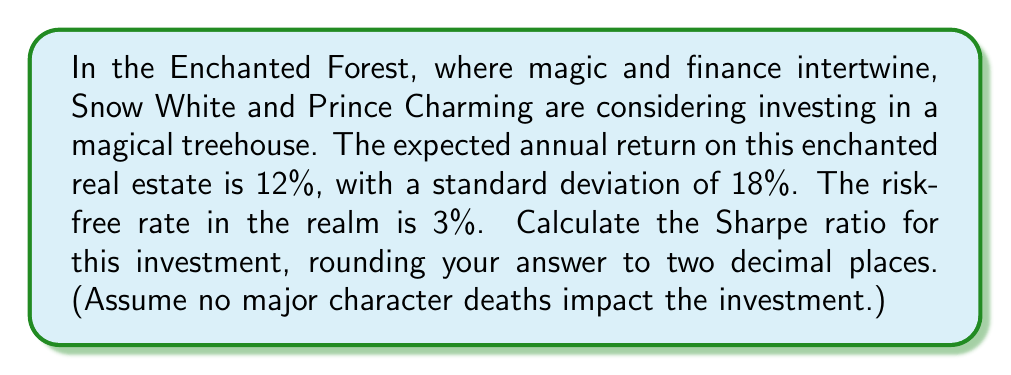Show me your answer to this math problem. To calculate the Sharpe ratio for the enchanted treehouse investment, we'll follow these steps:

1. Recall the formula for the Sharpe ratio:

   $$ \text{Sharpe Ratio} = \frac{R_p - R_f}{\sigma_p} $$

   Where:
   $R_p$ = Expected return of the portfolio (or investment)
   $R_f$ = Risk-free rate
   $\sigma_p$ = Standard deviation of the portfolio's excess return

2. We're given:
   - Expected annual return ($R_p$) = 12%
   - Standard deviation ($\sigma_p$) = 18%
   - Risk-free rate ($R_f$) = 3%

3. Let's substitute these values into the formula:

   $$ \text{Sharpe Ratio} = \frac{0.12 - 0.03}{0.18} $$

4. Calculate the numerator:
   $$ 0.12 - 0.03 = 0.09 $$

5. Now, divide by the standard deviation:
   $$ \frac{0.09}{0.18} = 0.5 $$

6. Round to two decimal places:
   $$ 0.50 $$

This Sharpe ratio indicates the risk-adjusted return of the enchanted treehouse investment, considering the magical nature of the Enchanted Forest real estate market.
Answer: 0.50 